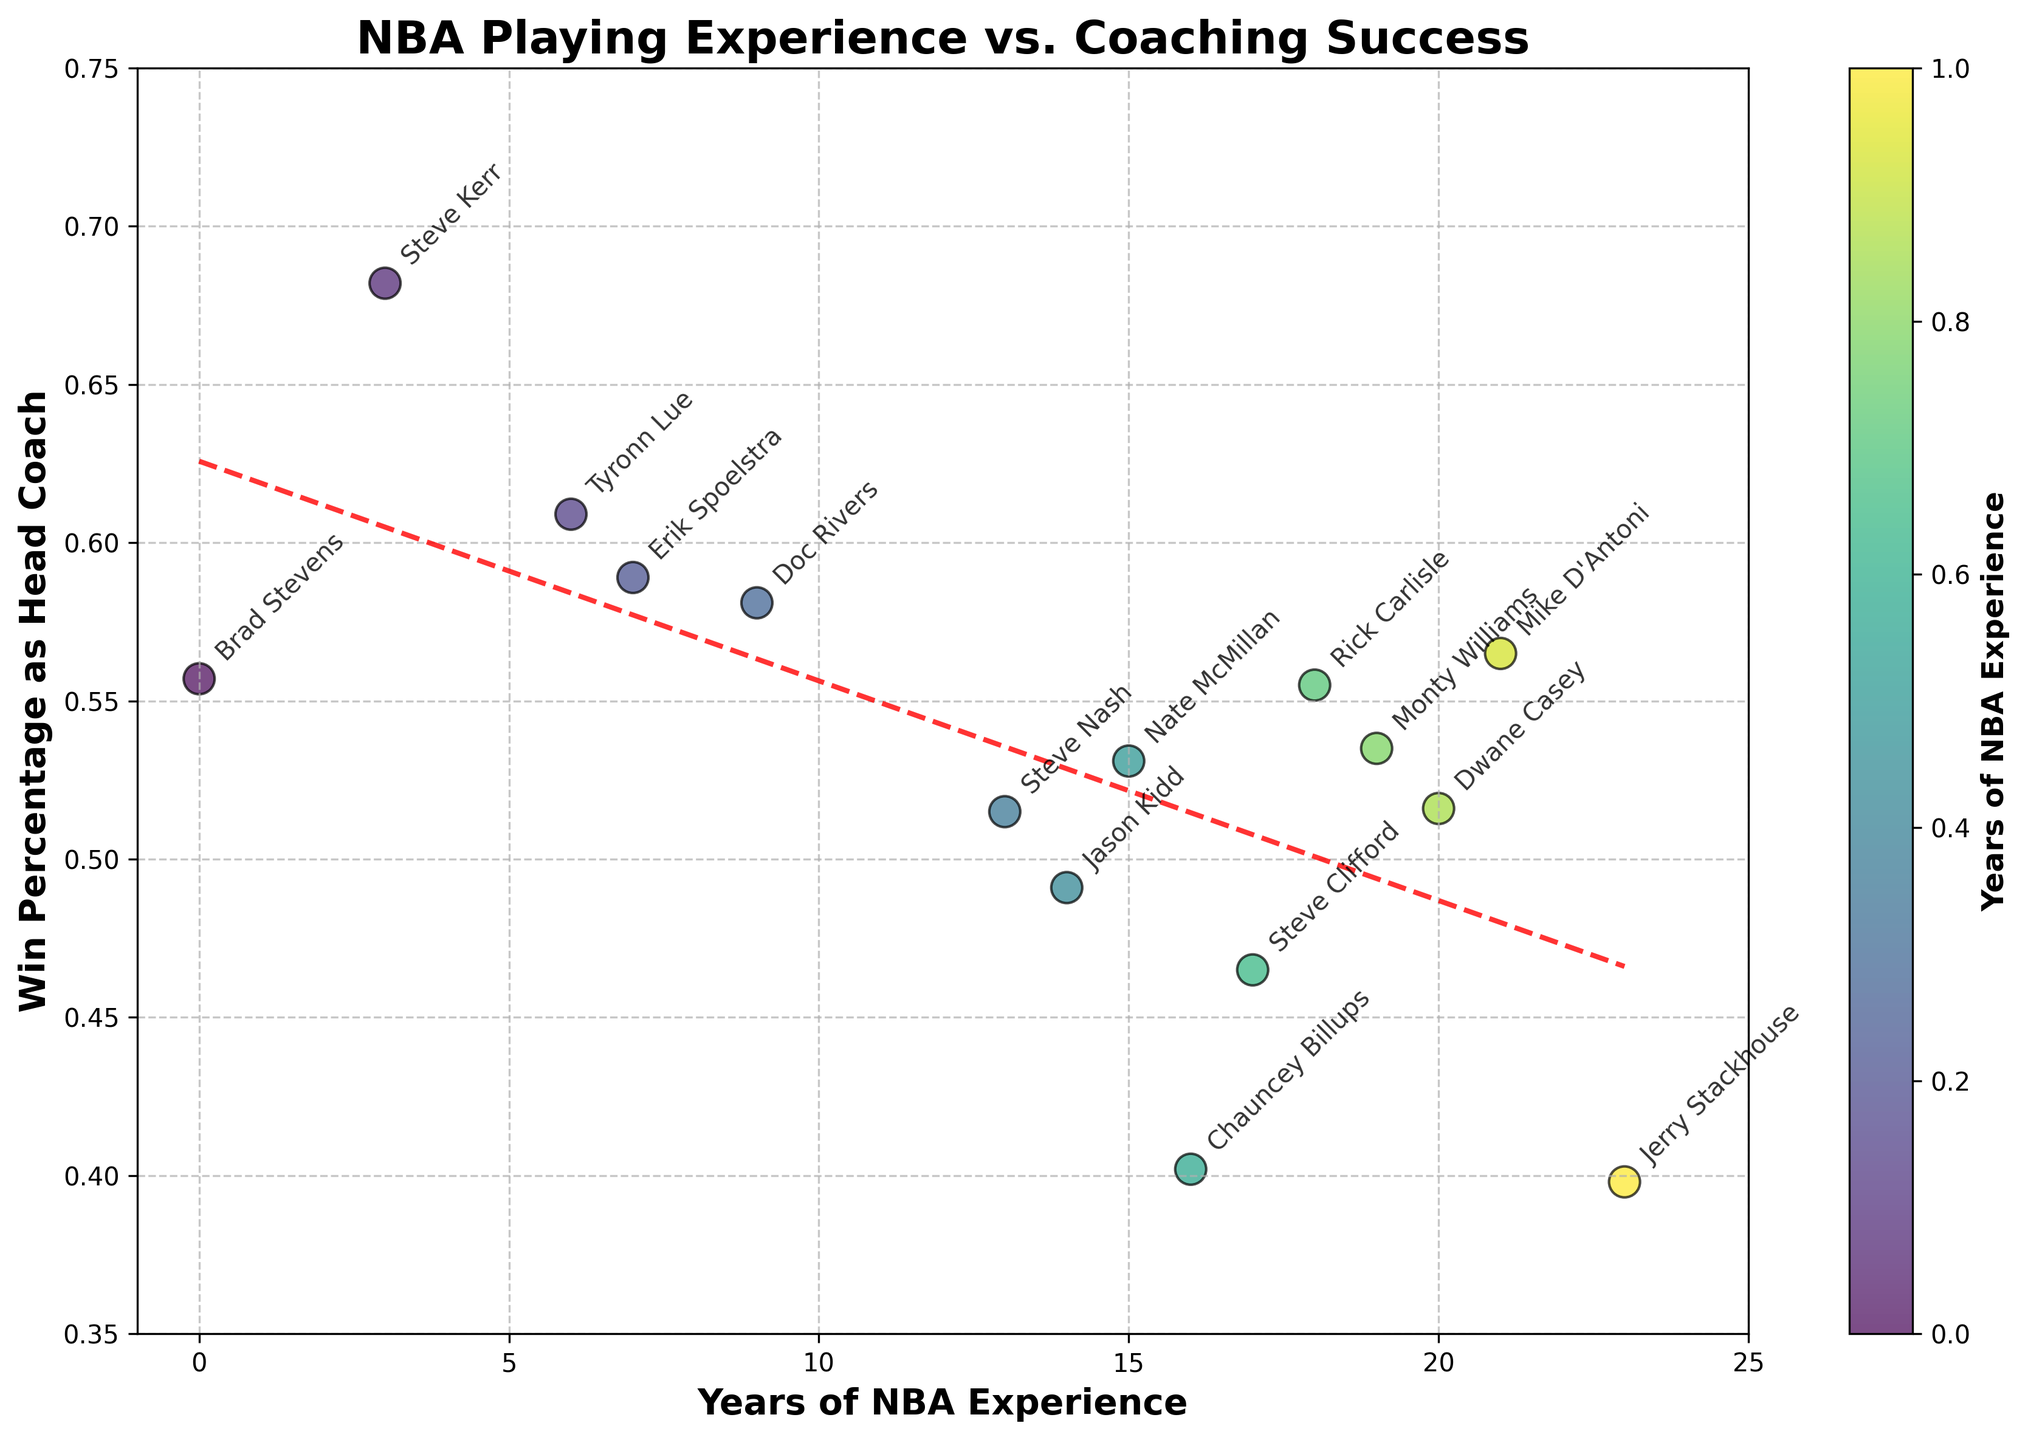What coach has the highest win percentage? To identify the coach with the highest win percentage, we look for the point highest along the y-axis. Steve Kerr is at the top with a win percentage of 0.682.
Answer: Steve Kerr What is the range of NBA playing experience among the coaches? The range is the difference between the maximum and minimum values of NBA playing experience. The maximum value is 23 (Jerry Stackhouse) and the minimum value is 0 (Brad Stevens). So the range is 23 - 0 = 23 years.
Answer: 23 years Which coach has the most NBA playing experience and what is their win percentage? By checking the x-axis, Jerry Stackhouse has the most NBA playing experience at 23 years and his win percentage is given as 0.398.
Answer: Jerry Stackhouse with win percentage 0.398 How does the win percentage trend with increasing NBA experience? To understand the trend, we observe the red dashed line representing the trendline in the plot. It shows a slight downward slope, suggesting a slight decrease in win percentage with more NBA experience.
Answer: Slight decrease Compare the win percentages of Steve Kerr and Erik Spoelstra. Who has a higher percentage and by how much? Steve Kerr's win percentage is 0.682, and Erik Spoelstra's is 0.589. Subtract the smaller percentage from the larger one: 0.682 - 0.589 = 0.093. So, Steve Kerr has a higher win percentage by 0.093.
Answer: Steve Kerr by 0.093 Who performed better as a coach: Rick Carlisle or Doc Rivers? By comparing their positions on the y-axis, Rick Carlisle has a win percentage of 0.555 and Doc Rivers has a win percentage of 0.581. Doc Rivers performed better.
Answer: Doc Rivers What is the average win percentage of coaches with more than 10 years of NBA experience? First, identify the coaches with more than 10 years of experience: Steve Nash, Jason Kidd, Nate McMillan, Chauncey Billups, Steve Clifford, Rick Carlisle, Monty Williams, Dwane Casey, Mike D'Antoni, and Jerry Stackhouse. Their win percentages are 0.515, 0.491, 0.531, 0.402, 0.465, 0.555, 0.535, 0.516, 0.565, 0.398 respectively. Calculate the average: sum these percentages (0.515 + 0.491 + 0.531 + 0.402 + 0.465 + 0.555 + 0.535 + 0.516 + 0.565 + 0.398) = 4.973. Divide by the number of coaches (10), resulting in 4.973 / 10 = 0.4973 or 49.73%.
Answer: 49.73% Is there any coach with more than 15 years of experience and a win percentage lower than 0.5? Look at the plot to identify coaches with more than 15 years of experience. Chauncey Billups (16 years, 0.402 win %), Steve Clifford (17 years, 0.465 win %), and Jerry Stackhouse (23 years, 0.398 win %), all have win percentages lower than 0.5.
Answer: Yes, three coaches What is the trendline equation for the data? From the code, the trendline equation is obtained using `np.polyfit`. By evaluating the plot, the trendline is of the form y = mx + b. The slope (m) and intercept (b) can be inferred from the given line description or trendline properties.
Answer: y = mx + b Identify the coach with 6 years of NBA experience. What is his win percentage? By looking at the x-axis for 6 years of experience, Tyronn Lue has a win percentage of 0.609.
Answer: Tyronn Lue with win percentage 0.609 